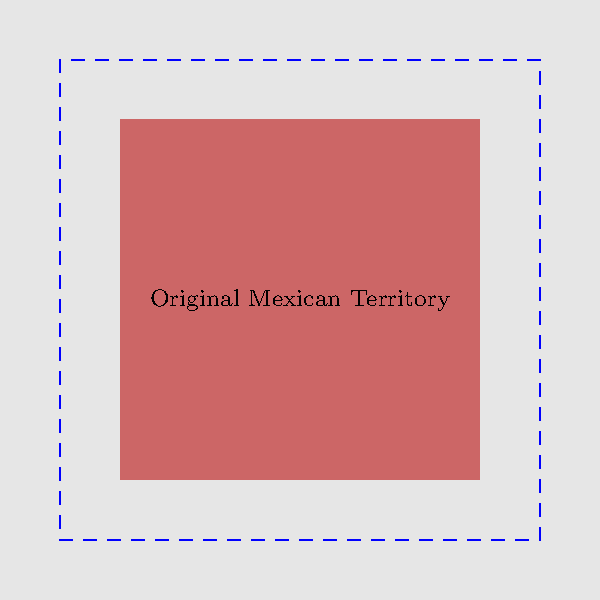Based on the map showing the territorial expansion of the Mexican Empire, approximately what percentage of land area was gained through expansion compared to the original territory? To determine the percentage of land area gained through expansion, let's follow these steps:

1. Observe the map: The original Mexican territory is shown in red, while the expanded area is outlined in blue.

2. Estimate the areas:
   - Original territory: Approximately 60x60 = 3600 square units
   - Expanded territory: Approximately 80x80 = 6400 square units

3. Calculate the difference:
   Expanded area - Original area = 6400 - 3600 = 2800 square units

4. Calculate the percentage increase:
   Percentage increase = (Area gained / Original area) x 100
   = (2800 / 3600) x 100
   ≈ 77.78%

5. Round to the nearest whole number:
   77.78% rounds to 78%

Therefore, the Mexican Empire gained approximately 78% more land area through expansion compared to its original territory.
Answer: 78% 